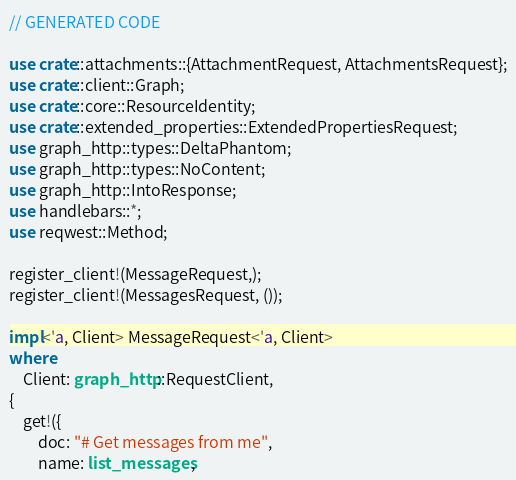Convert code to text. <code><loc_0><loc_0><loc_500><loc_500><_Rust_>// GENERATED CODE

use crate::attachments::{AttachmentRequest, AttachmentsRequest};
use crate::client::Graph;
use crate::core::ResourceIdentity;
use crate::extended_properties::ExtendedPropertiesRequest;
use graph_http::types::DeltaPhantom;
use graph_http::types::NoContent;
use graph_http::IntoResponse;
use handlebars::*;
use reqwest::Method;

register_client!(MessageRequest,);
register_client!(MessagesRequest, ());

impl<'a, Client> MessageRequest<'a, Client>
where
    Client: graph_http::RequestClient,
{
    get!({
        doc: "# Get messages from me",
        name: list_messages,</code> 